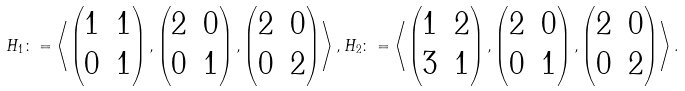Convert formula to latex. <formula><loc_0><loc_0><loc_500><loc_500>H _ { 1 } \colon = \left \langle \begin{pmatrix} 1 & 1 \\ 0 & 1 \end{pmatrix} , \begin{pmatrix} 2 & 0 \\ 0 & 1 \end{pmatrix} , \begin{pmatrix} 2 & 0 \\ 0 & 2 \end{pmatrix} \right \rangle , H _ { 2 } \colon = \left \langle \begin{pmatrix} 1 & 2 \\ 3 & 1 \end{pmatrix} , \begin{pmatrix} 2 & 0 \\ 0 & 1 \end{pmatrix} , \begin{pmatrix} 2 & 0 \\ 0 & 2 \end{pmatrix} \right \rangle .</formula> 